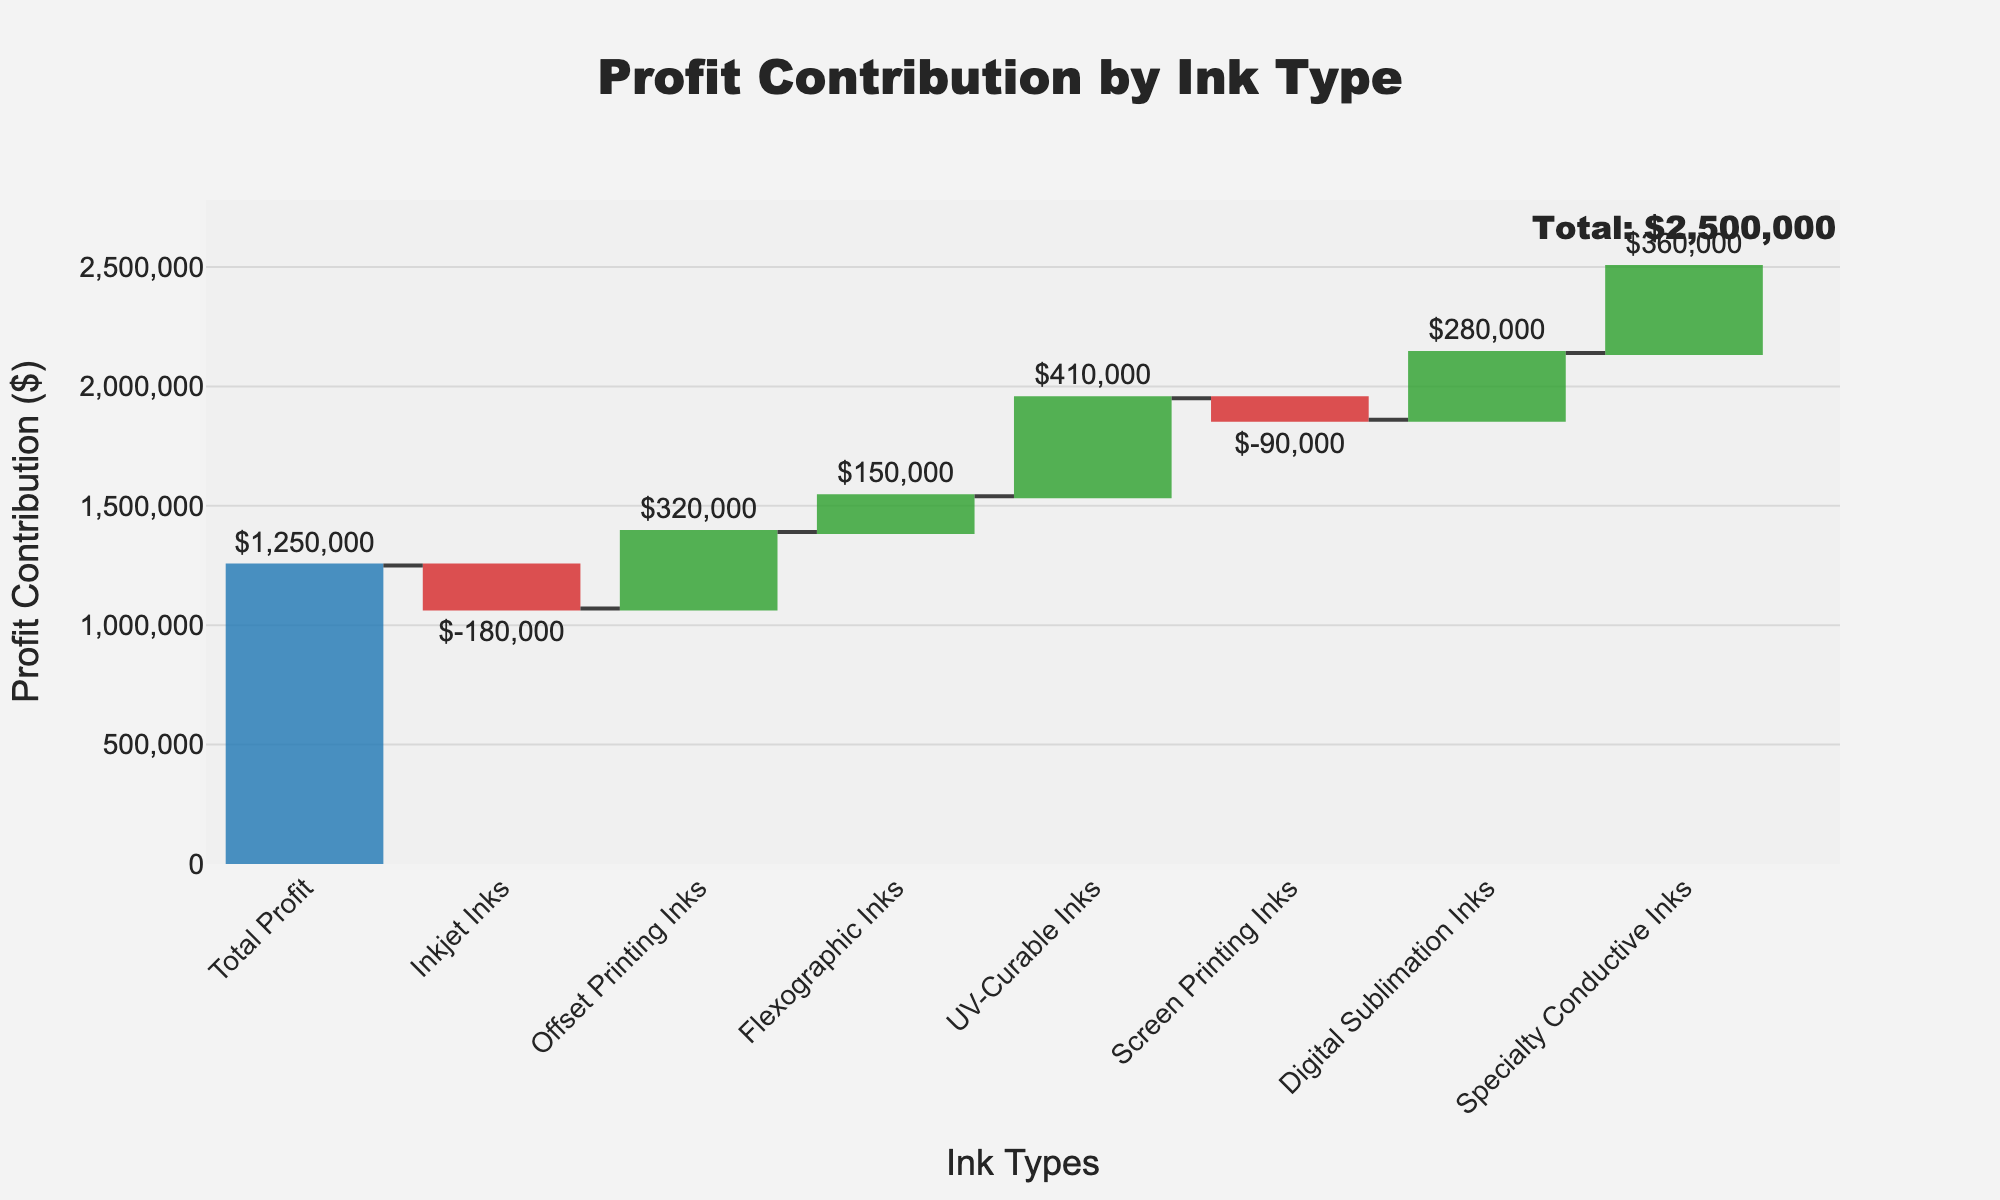What's the title of the chart? The title of the chart is located at the top and is designed to quickly inform the viewer about the overall topic of the chart. Simply reading the text there will provide the answer.
Answer: Profit Contribution by Ink Type Which ink type has the largest positive profit contribution? To find the ink type with the largest positive profit contribution, look for the tallest green bar in the chart, as green indicates an increase in profit. The label at the bottom of this bar provides the ink type.
Answer: UV-Curable Inks How much is the total profit contribution? To determine the total profit contribution, look at the annotation or label near the end of the chart, typically marked "Total" or calculated to the rightmost part of the waterfall chart.
Answer: $1,250,000 What is the worst-performing ink type in terms of profit? Identify the ink type with the greatest negative value by locating the largest red bar in the chart. The label at the bottom of the bar gives the name of the ink type.
Answer: Inkjet Inks How does the profit contribution of Digital Sublimation Inks compare to Offset Printing Inks? Compare the heights of the positive bars for Digital Sublimation Inks and Offset Printing Inks, paying attention to the values indicated next to or on top of these bars to determine which is higher.
Answer: Offset Printing Inks (greater) What is the combined profit contribution of Flexographic and Screen Printing Inks? Find the values associated with Flexographic Inks and Screen Printing Inks. Add these values together to get the total combined contribution.
Answer: $60,000 ((150,000) + (-90,000)) What is the profit contribution difference between Specialty Conductive Inks and Inkjet Inks? Subtract the value of Inkjet Inks from Specialty Conductive Inks. This involves taking the positive value of Specialty Conductive Inks and subtracting the negative value of Inkjet Inks.
Answer: $540,000 (360,000 - (-180,000)) Which ink types have negative profit contributions? Look for red bars in the chart, indicating a negative profit contribution. Note the ink types associated with these bars.
Answer: Inkjet Inks, Screen Printing Inks What would be the total profit if UV-Curable Inks were excluded? Subtract the profit contribution of UV-Curable Inks from the total profit. This requires removing the UV-Curable Inks' value from the overall total provided in the chart.
Answer: $840,000 (1,250,000 - 410,000) 华印墨水 the 头 差额? As the final waterfall value marked at the end of the chart is the cumulative profit, you can read the overall profit at the adjacent location. Making clear to pinpoint down 头 差额
Answer: 1,250,000 